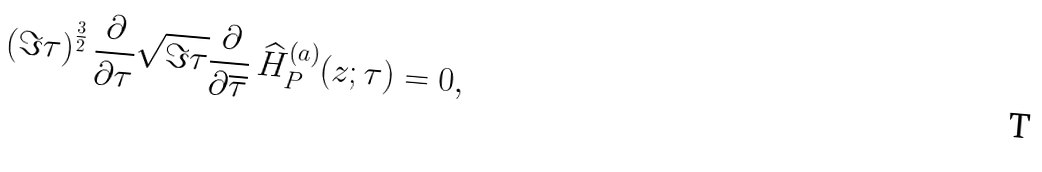<formula> <loc_0><loc_0><loc_500><loc_500>\left ( \Im \tau \right ) ^ { \frac { 3 } { 2 } } \frac { \partial } { \partial \tau } \sqrt { \Im \tau } \frac { \partial } { \partial \overline { \tau } } \, \widehat { H } _ { P } ^ { ( a ) } ( z ; \tau ) = 0 ,</formula> 